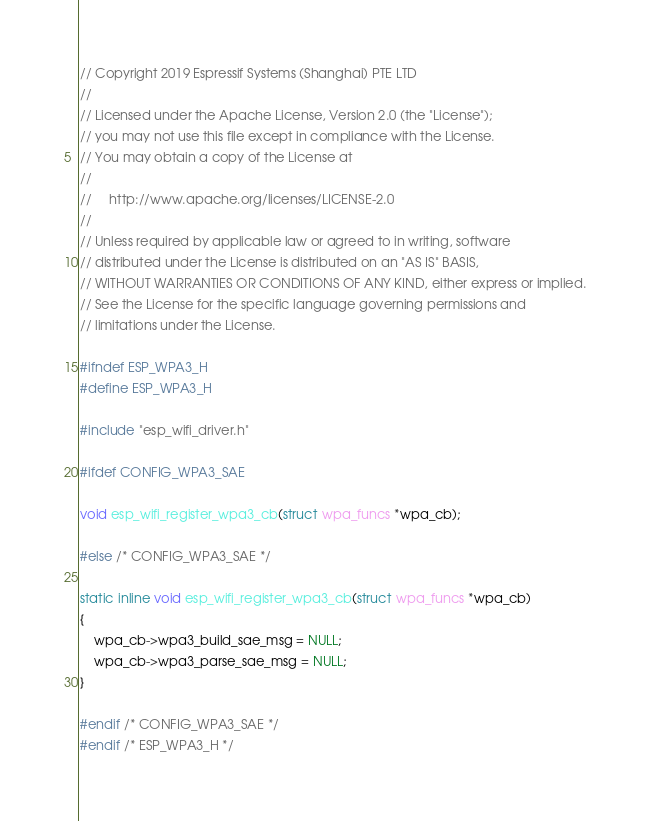<code> <loc_0><loc_0><loc_500><loc_500><_C_>
// Copyright 2019 Espressif Systems (Shanghai) PTE LTD
//
// Licensed under the Apache License, Version 2.0 (the "License");
// you may not use this file except in compliance with the License.
// You may obtain a copy of the License at
//
//     http://www.apache.org/licenses/LICENSE-2.0
//
// Unless required by applicable law or agreed to in writing, software
// distributed under the License is distributed on an "AS IS" BASIS,
// WITHOUT WARRANTIES OR CONDITIONS OF ANY KIND, either express or implied.
// See the License for the specific language governing permissions and
// limitations under the License.

#ifndef ESP_WPA3_H
#define ESP_WPA3_H

#include "esp_wifi_driver.h"

#ifdef CONFIG_WPA3_SAE

void esp_wifi_register_wpa3_cb(struct wpa_funcs *wpa_cb);

#else /* CONFIG_WPA3_SAE */

static inline void esp_wifi_register_wpa3_cb(struct wpa_funcs *wpa_cb)
{
    wpa_cb->wpa3_build_sae_msg = NULL;
    wpa_cb->wpa3_parse_sae_msg = NULL;
}

#endif /* CONFIG_WPA3_SAE */
#endif /* ESP_WPA3_H */
</code> 